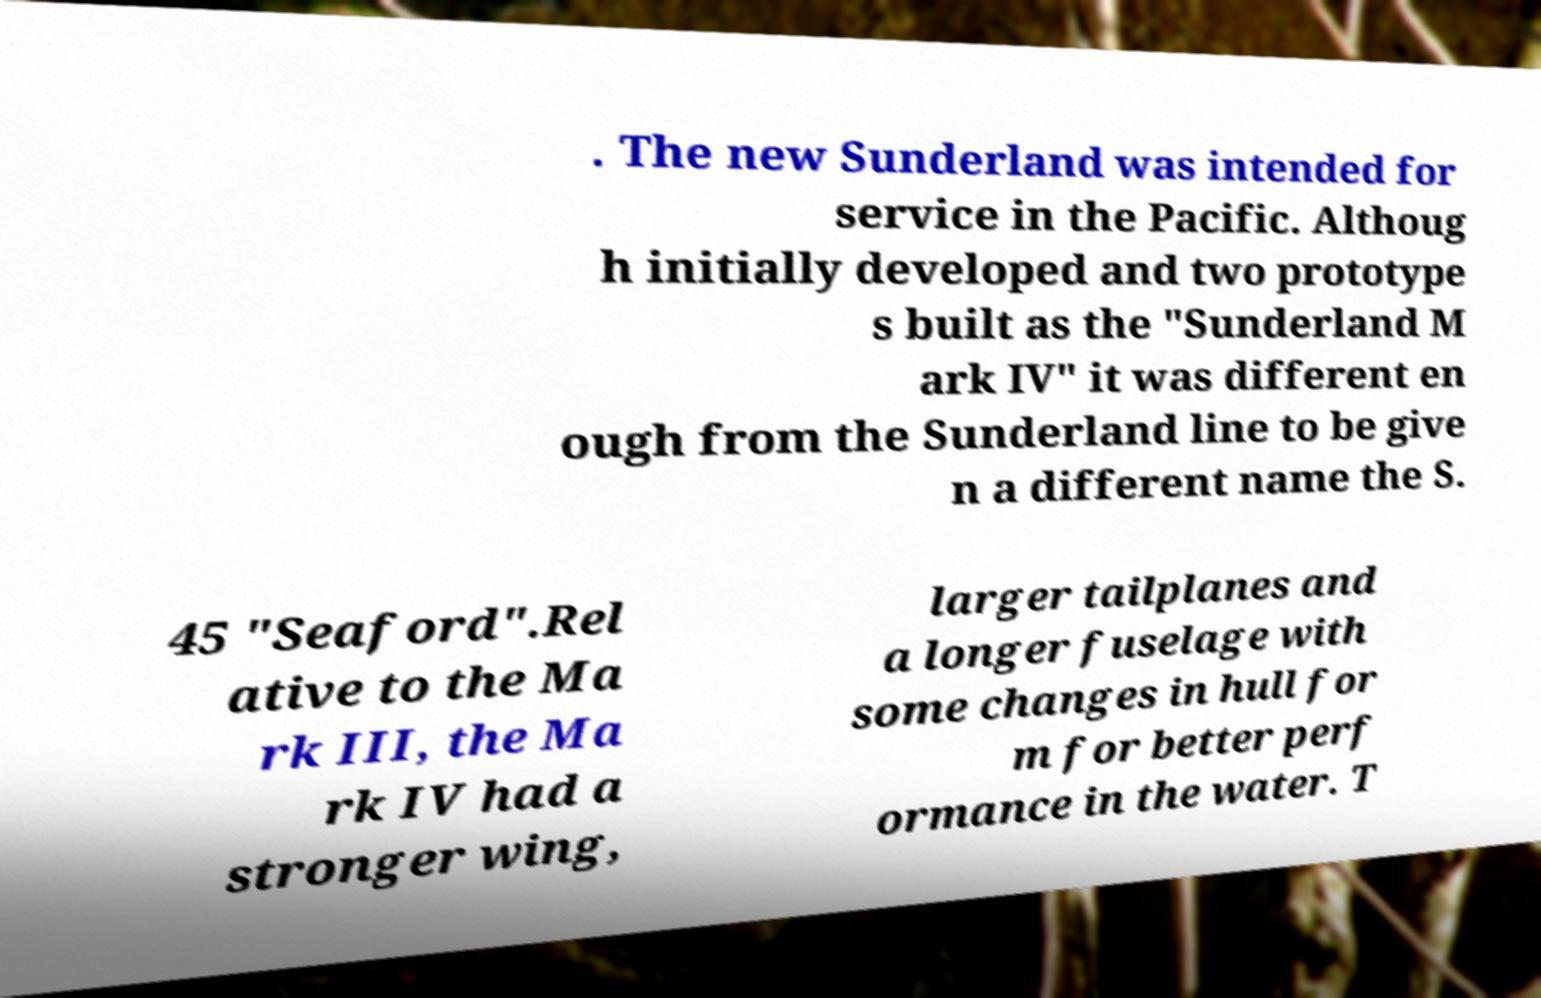Please read and relay the text visible in this image. What does it say? . The new Sunderland was intended for service in the Pacific. Althoug h initially developed and two prototype s built as the "Sunderland M ark IV" it was different en ough from the Sunderland line to be give n a different name the S. 45 "Seaford".Rel ative to the Ma rk III, the Ma rk IV had a stronger wing, larger tailplanes and a longer fuselage with some changes in hull for m for better perf ormance in the water. T 